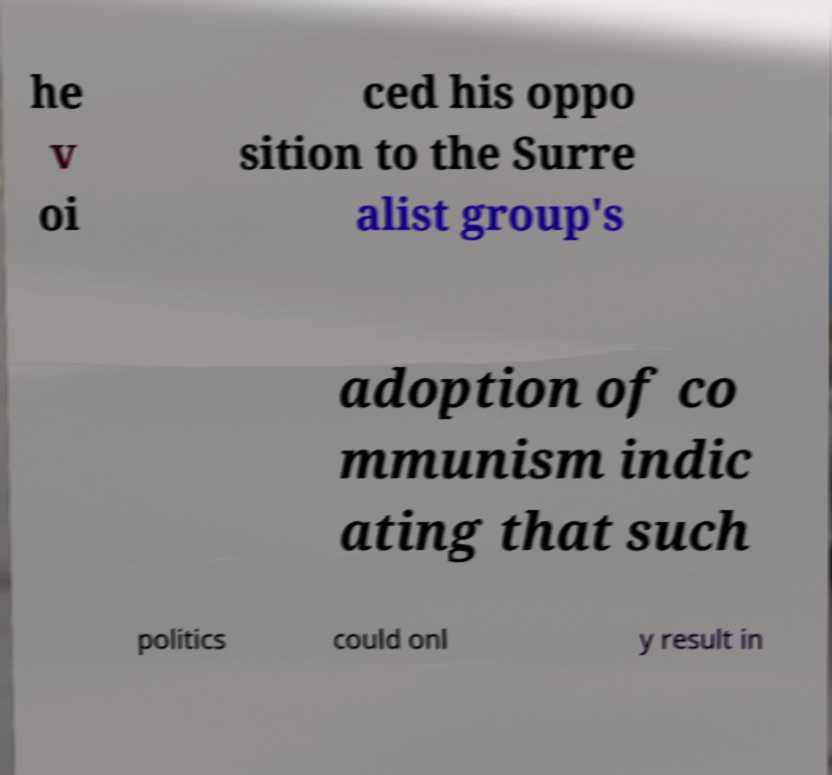There's text embedded in this image that I need extracted. Can you transcribe it verbatim? he v oi ced his oppo sition to the Surre alist group's adoption of co mmunism indic ating that such politics could onl y result in 